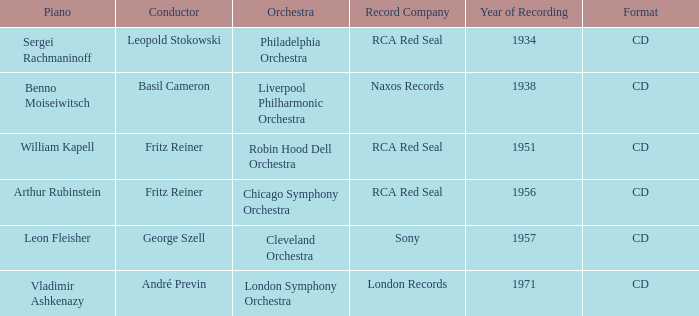Where is the orchestra situated during the 1934 recording? Philadelphia Orchestra. 